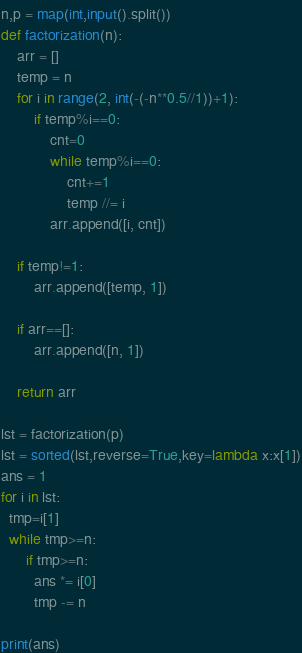Convert code to text. <code><loc_0><loc_0><loc_500><loc_500><_Python_>n,p = map(int,input().split())
def factorization(n):
    arr = []
    temp = n
    for i in range(2, int(-(-n**0.5//1))+1):
        if temp%i==0:
            cnt=0
            while temp%i==0:
                cnt+=1
                temp //= i
            arr.append([i, cnt])

    if temp!=1:
        arr.append([temp, 1])

    if arr==[]:
        arr.append([n, 1])

    return arr

lst = factorization(p)
lst = sorted(lst,reverse=True,key=lambda x:x[1])
ans = 1
for i in lst:
  tmp=i[1]
  while tmp>=n:
      if tmp>=n:
        ans *= i[0]
        tmp -= n
      
print(ans) </code> 